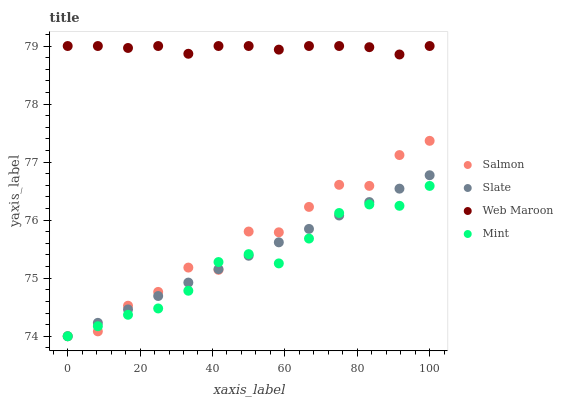Does Mint have the minimum area under the curve?
Answer yes or no. Yes. Does Web Maroon have the maximum area under the curve?
Answer yes or no. Yes. Does Slate have the minimum area under the curve?
Answer yes or no. No. Does Slate have the maximum area under the curve?
Answer yes or no. No. Is Slate the smoothest?
Answer yes or no. Yes. Is Salmon the roughest?
Answer yes or no. Yes. Is Salmon the smoothest?
Answer yes or no. No. Is Slate the roughest?
Answer yes or no. No. Does Slate have the lowest value?
Answer yes or no. Yes. Does Web Maroon have the highest value?
Answer yes or no. Yes. Does Slate have the highest value?
Answer yes or no. No. Is Salmon less than Web Maroon?
Answer yes or no. Yes. Is Web Maroon greater than Salmon?
Answer yes or no. Yes. Does Salmon intersect Slate?
Answer yes or no. Yes. Is Salmon less than Slate?
Answer yes or no. No. Is Salmon greater than Slate?
Answer yes or no. No. Does Salmon intersect Web Maroon?
Answer yes or no. No. 